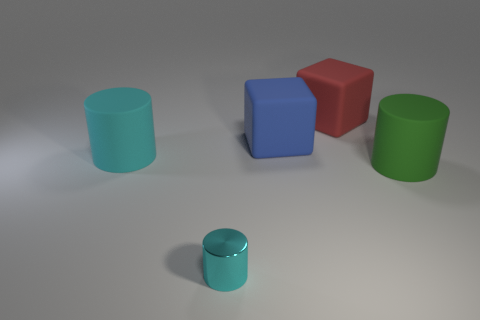Is there any other thing that is made of the same material as the tiny cyan cylinder?
Give a very brief answer. No. How many other rubber objects have the same shape as the large green thing?
Ensure brevity in your answer.  1. There is a big green matte thing; is it the same shape as the blue rubber object that is to the right of the tiny thing?
Provide a succinct answer. No. There is a tiny metallic thing; what number of big objects are to the left of it?
Your response must be concise. 1. Is there a purple matte cube that has the same size as the cyan rubber thing?
Ensure brevity in your answer.  No. There is a matte object to the left of the small shiny thing; is its shape the same as the tiny object?
Your answer should be very brief. Yes. The shiny cylinder is what color?
Make the answer very short. Cyan. The other object that is the same color as the tiny object is what shape?
Your answer should be compact. Cylinder. Are any small gray matte cylinders visible?
Ensure brevity in your answer.  No. What is the size of the blue cube that is the same material as the large green cylinder?
Your answer should be compact. Large. 